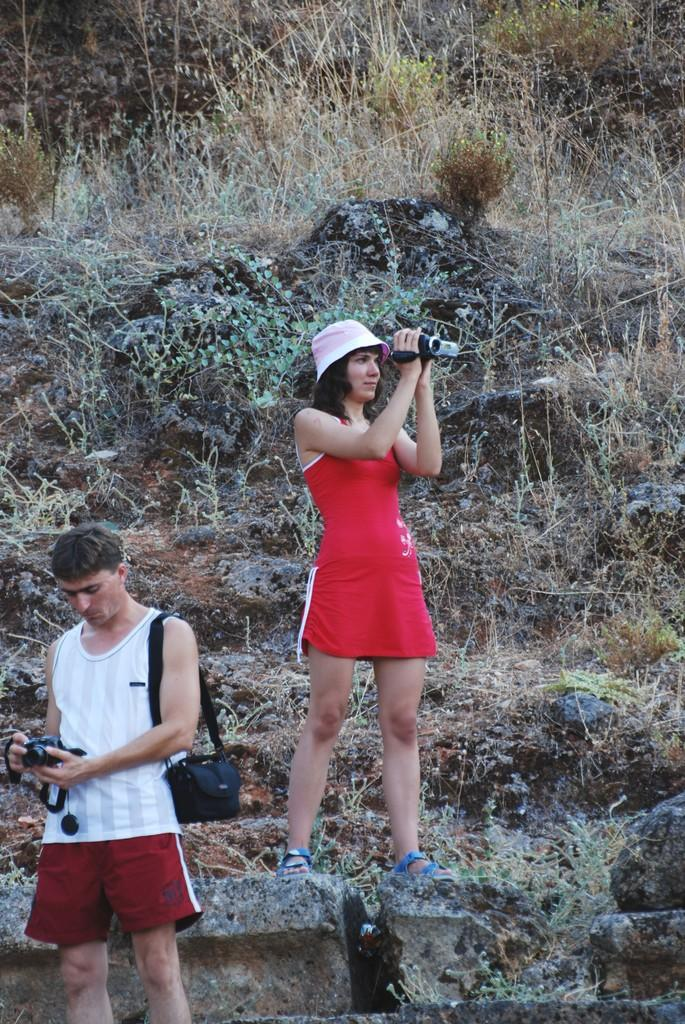How many people are in the image? There are two persons in the image. What are the persons holding in the image? The persons are holding cameras. What can be seen in the background of the image? There are plants and stones in the background of the image. Can you see any mice playing volleyball in the image? No, there are no mice or volleyball present in the image. 